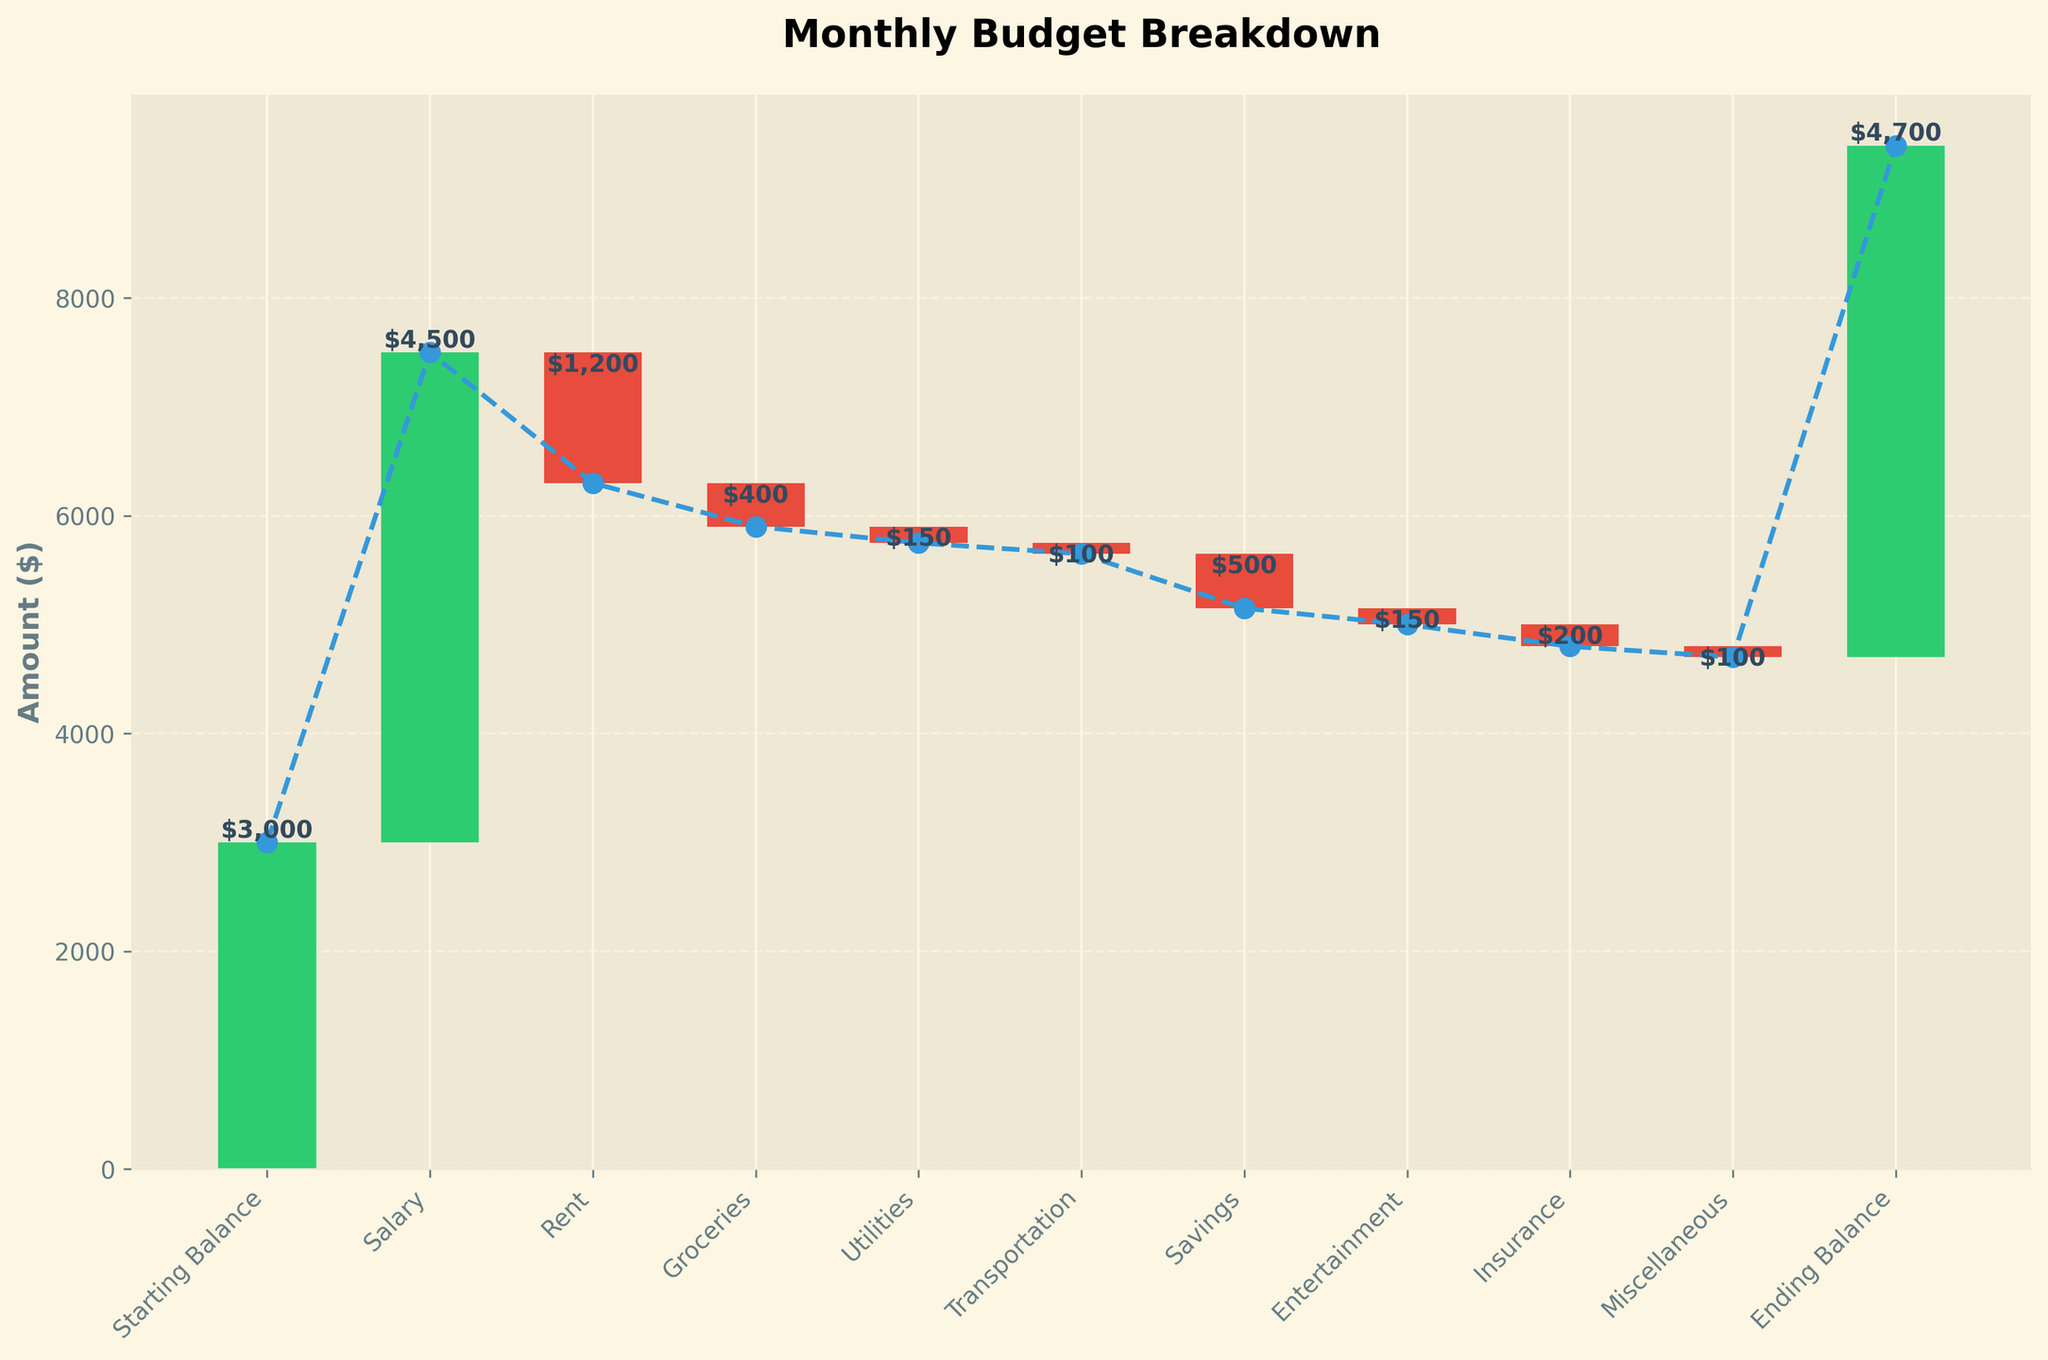what is the title of the chart? The title of the chart is displayed at the top, which reads "Monthly Budget Breakdown".
Answer: Monthly Budget Breakdown How many categories are listed in the chart? By counting the data labels on the x-axis, we can see that there are 11 categories listed in the chart.
Answer: 11 What is the ending balance shown in the chart? The ending balance is represented as the last bar in the figure, which shows an amount of $4,700.
Answer: $4,700 Which category has the largest positive contribution to the budget? By comparing all the positive bars in the chart, the category "Salary" has the largest positive contribution, amounting to $4,500.
Answer: Salary What is the total amount spent on expenses (summation of negative values)? Adding up all the negative contributions: -$1,200 (Rent), -$400 (Groceries), -$150 (Utilities), -$100 (Transportation), -$500 (Savings), -$150 (Entertainment), -$200 (Insurance), -$100 (Miscellaneous) gives a total of -$2,800.
Answer: $2,800 Which category contributes to the most significant negative change? By comparing all the negative bars in the chart, "Rent" has the most significant negative change with a value of -$1,200.
Answer: Rent How does the total income compare to the total expenses? The total income can be found by adding the positive amounts (Starting Balance $3000, Salary $4500) which totals $7500. The total expense is the summation of the negative values (-$2800). The income exceeds the expenses by $7500 - $2800 = $4700.
Answer: Income exceeds expenses by $4700 What are the cumulative values at the highest and lowest points? The highest cumulative value is at the last category "Ending Balance" which is $4,700 and the lowest cumulative value is after "Rent" which is $6,300.5 ($3,000 + $4,500 - $1,200).
Answer: Highest: $4,700, Lowest: $6,300.5 What is the net increase or decrease in the budget? The net change is determined by the difference between the Ending Balance and the Starting Balance. Ending Balance is $4,700 and Starting Balance is $3,000, so the net increase is $4,700 - $3,000 = $1,700.
Answer: Net increase: $1,700 